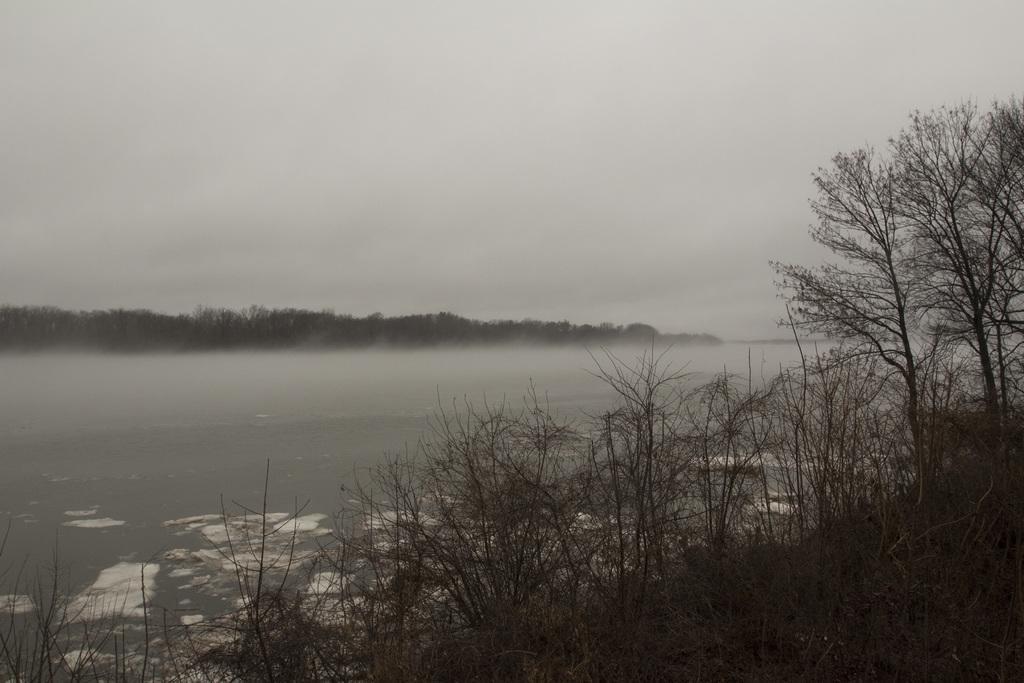Please provide a concise description of this image. At the bottom of the image there are plants without leaves. Behind the plants there is water. In the background there are trees. And there is a white background. 